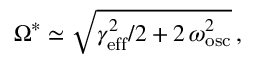<formula> <loc_0><loc_0><loc_500><loc_500>\Omega ^ { * } \simeq \sqrt { \gamma _ { e f f } ^ { 2 } / 2 + 2 \, \omega _ { o s c } ^ { 2 } } \, ,</formula> 